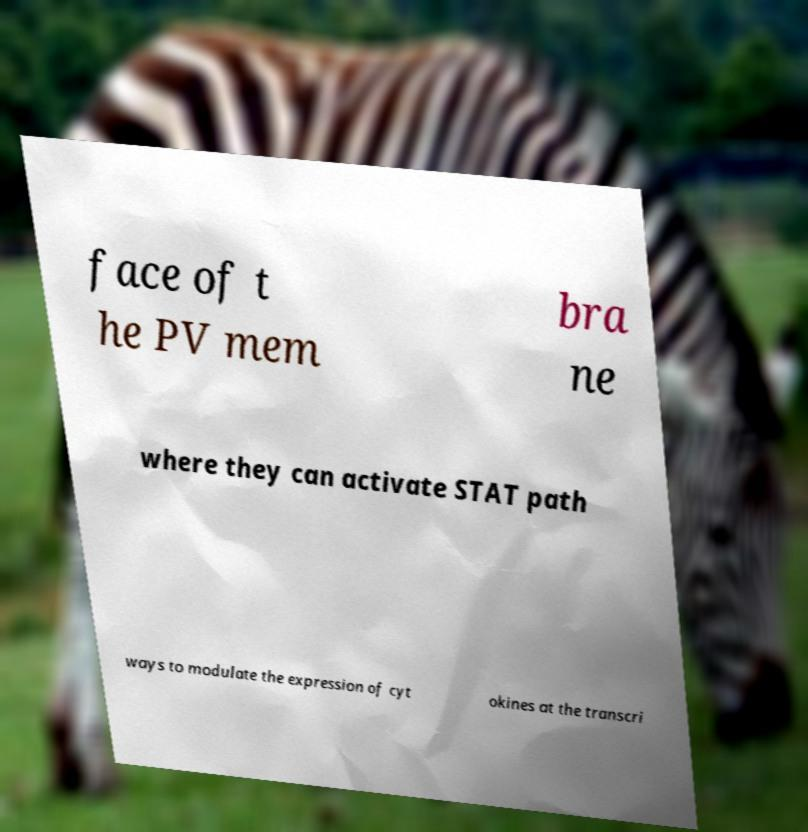Can you read and provide the text displayed in the image?This photo seems to have some interesting text. Can you extract and type it out for me? face of t he PV mem bra ne where they can activate STAT path ways to modulate the expression of cyt okines at the transcri 